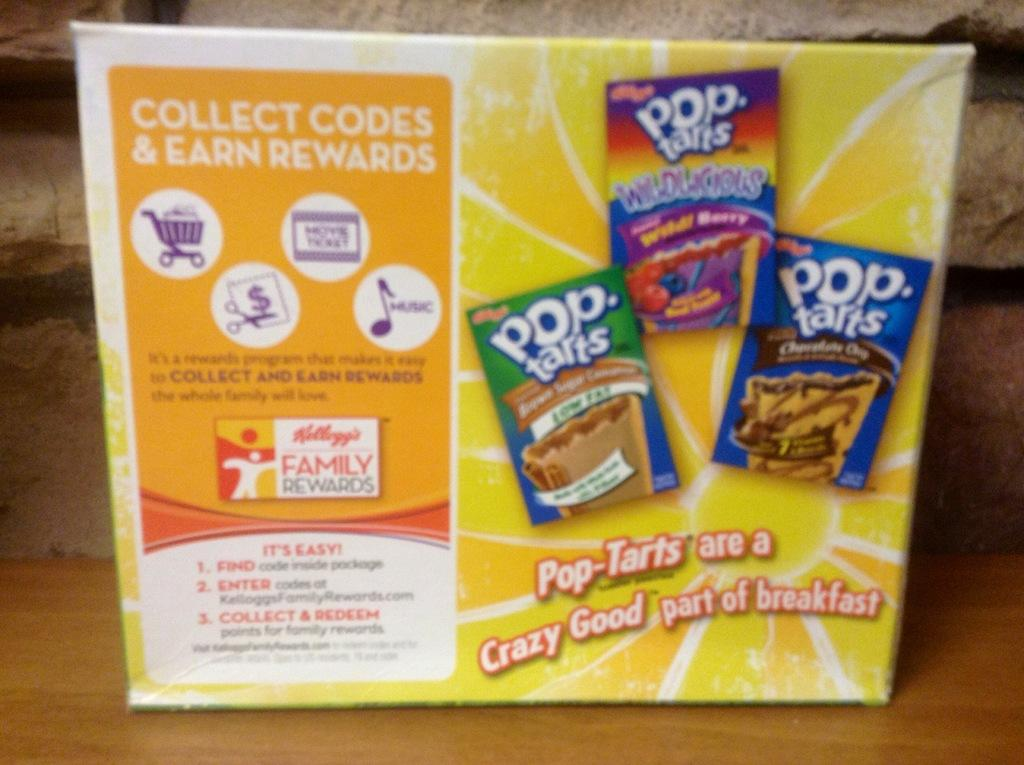What object is placed on the table in the image? There is a box placed on a table in the image. What can be found on the surface of the box? There is text and images of boxes on the box. What is the background of the image? There is a wall visible in the background of the image. What type of wood is used to make the oven in the image? There is no oven present in the image; it features a box placed on a table. What type of beef is being prepared in the image? There is no beef or any food preparation visible in the image. 